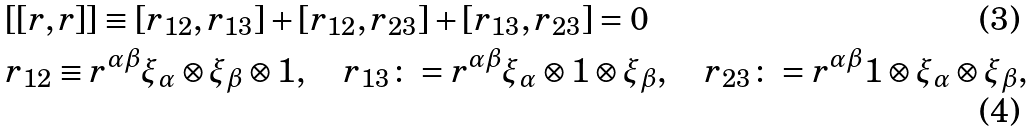Convert formula to latex. <formula><loc_0><loc_0><loc_500><loc_500>& [ [ r , r ] ] \equiv [ r _ { 1 2 } , r _ { 1 3 } ] + [ r _ { 1 2 } , r _ { 2 3 } ] + [ r _ { 1 3 } , r _ { 2 3 } ] = 0 \\ & r _ { 1 2 } \equiv r ^ { \alpha \beta } \xi _ { \alpha } \otimes \xi _ { \beta } \otimes 1 , \quad r _ { 1 3 } \colon = r ^ { \alpha \beta } \xi _ { \alpha } \otimes 1 \otimes \xi _ { \beta } , \quad r _ { 2 3 } \colon = r ^ { \alpha \beta } 1 \otimes \xi _ { \alpha } \otimes \xi _ { \beta } ,</formula> 